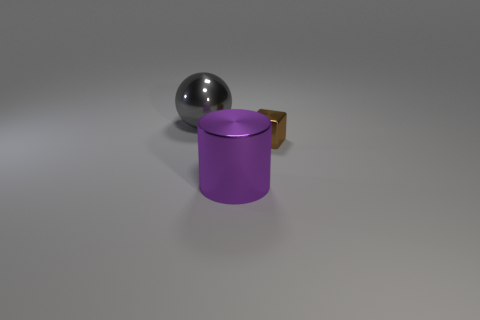Do the block and the gray metallic object have the same size?
Make the answer very short. No. The purple thing that is made of the same material as the tiny brown cube is what shape?
Your response must be concise. Cylinder. What number of other things are there of the same shape as the tiny brown metallic thing?
Make the answer very short. 0. There is a big metal thing behind the big object in front of the big thing behind the metallic block; what shape is it?
Provide a short and direct response. Sphere. How many blocks are large gray metal things or brown metal objects?
Provide a short and direct response. 1. There is a big thing that is behind the large cylinder; is there a purple shiny thing to the left of it?
Make the answer very short. No. Is there anything else that has the same material as the brown object?
Offer a terse response. Yes. There is a small shiny thing; is its shape the same as the large object in front of the large sphere?
Ensure brevity in your answer.  No. How many other things are there of the same size as the brown object?
Offer a terse response. 0. What number of brown objects are metallic spheres or cubes?
Make the answer very short. 1. 